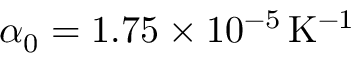Convert formula to latex. <formula><loc_0><loc_0><loc_500><loc_500>\alpha _ { 0 } = 1 . 7 5 \times 1 0 ^ { - 5 } \, K ^ { - 1 }</formula> 